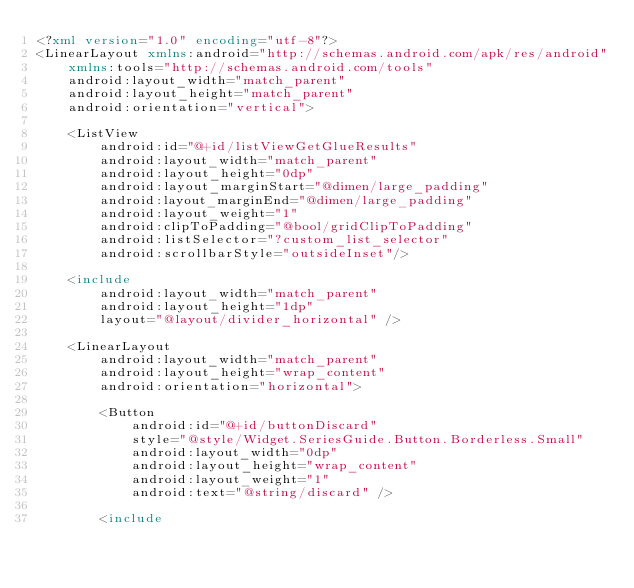<code> <loc_0><loc_0><loc_500><loc_500><_XML_><?xml version="1.0" encoding="utf-8"?>
<LinearLayout xmlns:android="http://schemas.android.com/apk/res/android"
    xmlns:tools="http://schemas.android.com/tools"
    android:layout_width="match_parent"
    android:layout_height="match_parent"
    android:orientation="vertical">

    <ListView
        android:id="@+id/listViewGetGlueResults"
        android:layout_width="match_parent"
        android:layout_height="0dp"
        android:layout_marginStart="@dimen/large_padding"
        android:layout_marginEnd="@dimen/large_padding"
        android:layout_weight="1"
        android:clipToPadding="@bool/gridClipToPadding"
        android:listSelector="?custom_list_selector"
        android:scrollbarStyle="outsideInset"/>

    <include
        android:layout_width="match_parent"
        android:layout_height="1dp"
        layout="@layout/divider_horizontal" />

    <LinearLayout
        android:layout_width="match_parent"
        android:layout_height="wrap_content"
        android:orientation="horizontal">

        <Button
            android:id="@+id/buttonDiscard"
            style="@style/Widget.SeriesGuide.Button.Borderless.Small"
            android:layout_width="0dp"
            android:layout_height="wrap_content"
            android:layout_weight="1"
            android:text="@string/discard" />

        <include</code> 